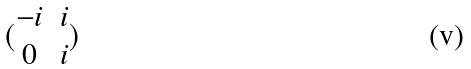<formula> <loc_0><loc_0><loc_500><loc_500>( \begin{matrix} - i & i \\ 0 & i \end{matrix} )</formula> 